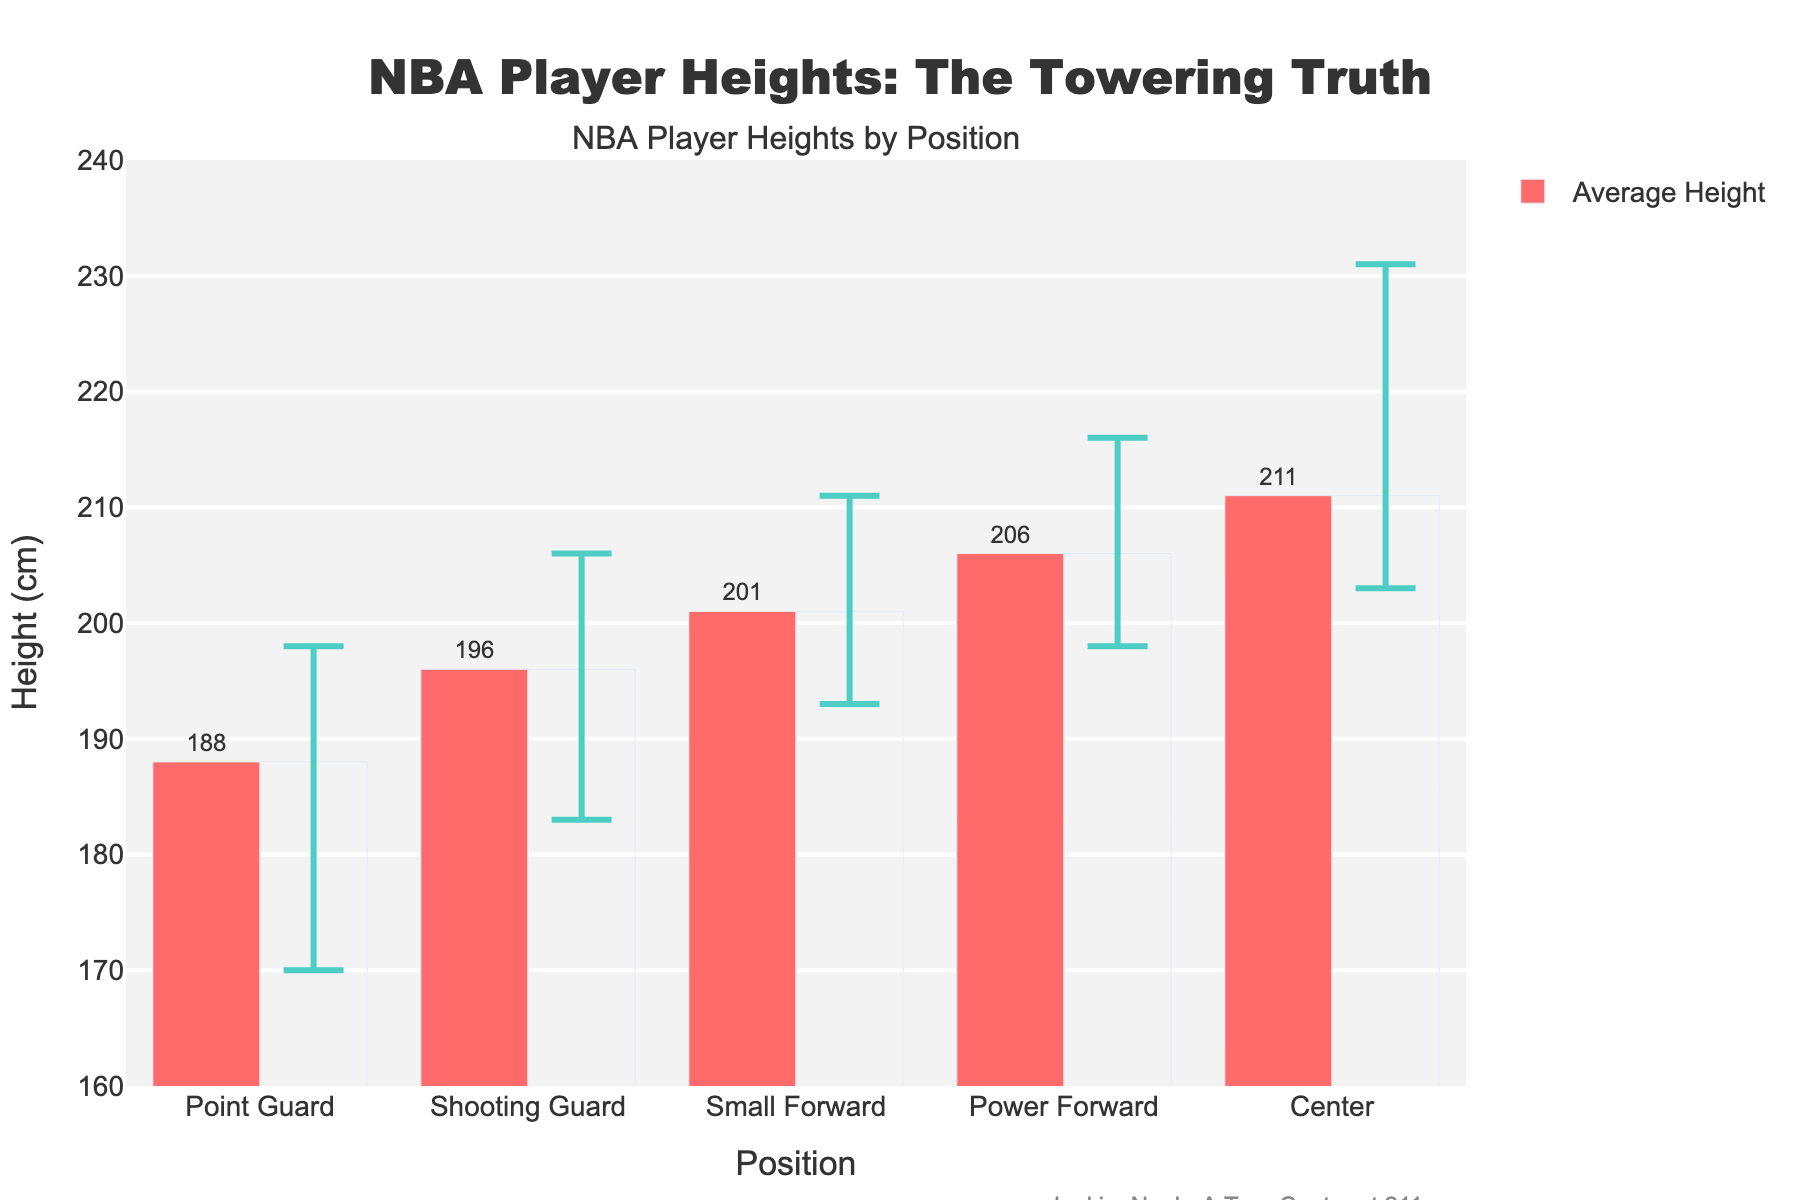What's the average height of players playing as Centers? Look at the bar for the "Center" position and refer to the text above the bar to see the average height value.
Answer: 211 cm Which position has the tallest maximum height, and what is that height? Observe the error bars and their upper bound for each position. The "Center" position has the tallest maximum height at 231 cm, as indicated by the longest error bar.
Answer: Center, 231 cm What is the difference between the average height of Power Forwards and Point Guards? Subtract the average height of Point Guards (188 cm) from the average height of Power Forwards (206 cm). The difference is 206 - 188 = 18 cm.
Answer: 18 cm Which position has the smallest range in height? Compare the length of the error bars for each position. The "Point Guard" position, with a range from 170 cm to 198 cm, has the smallest range of 28 cm.
Answer: Point Guard For which position is the average height closest to Joakim Noah's height (211 cm)? Observe the bars and find which one is closest to 211 cm. The "Center" position has an average height of 211 cm, which matches Joakim Noah's height exactly.
Answer: Center What’s the average of the maximum heights for all positions? Sum all the maximum heights (198 + 206 + 211 + 216 + 231) and divide by the number of positions (5). The average is (198 + 206 + 211 + 216 + 231) / 5 = 1062 / 5 = 212.4 cm.
Answer: 212.4 cm Which two positions have the closest average height, and what are those heights? Look for bars with the closest height values. "Shooting Guard" and "Small Forward" have the closest average heights of 196 cm and 201 cm, respectively, with a difference of 5 cm.
Answer: Shooting Guard (196 cm) and Small Forward (201 cm) Is there any position where the minimum height is above 200 cm? Check the lower bound of the error bars. The "Center" position has a minimum height of 203 cm, which is above 200 cm.
Answer: Yes, Center Visualize the color of the bars representing the average height in the chart and describe it. All of the bars representing the average height are colored in red.
Answer: Red 